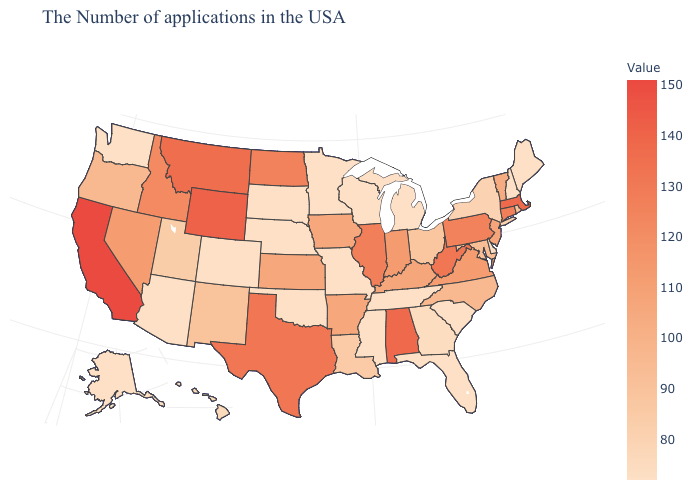Is the legend a continuous bar?
Give a very brief answer. Yes. Does the map have missing data?
Quick response, please. No. Among the states that border North Dakota , does Montana have the lowest value?
Write a very short answer. No. 